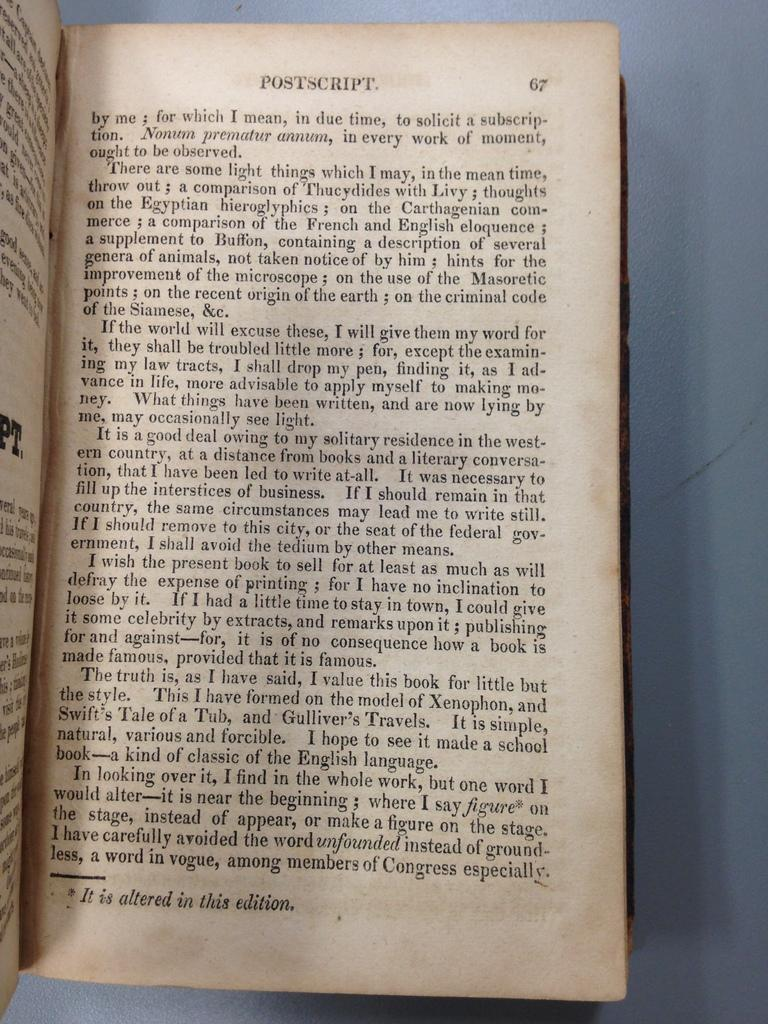<image>
Write a terse but informative summary of the picture. The open book is turned to page 67 